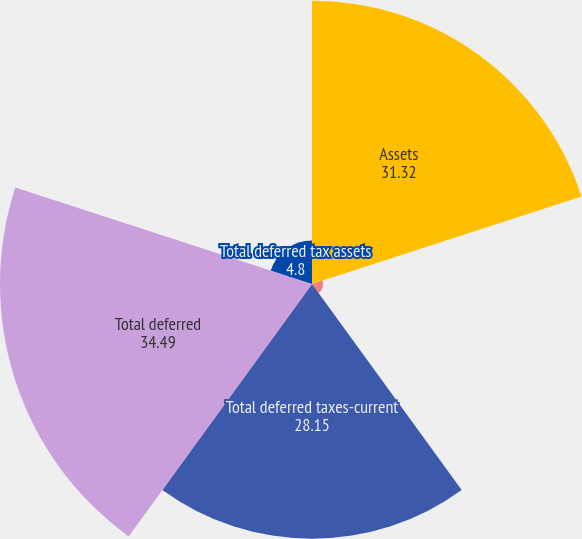<chart> <loc_0><loc_0><loc_500><loc_500><pie_chart><fcel>Assets<fcel>Liabilities<fcel>Total deferred taxes-current<fcel>Total deferred<fcel>Total deferred tax assets<nl><fcel>31.32%<fcel>1.23%<fcel>28.15%<fcel>34.49%<fcel>4.8%<nl></chart> 